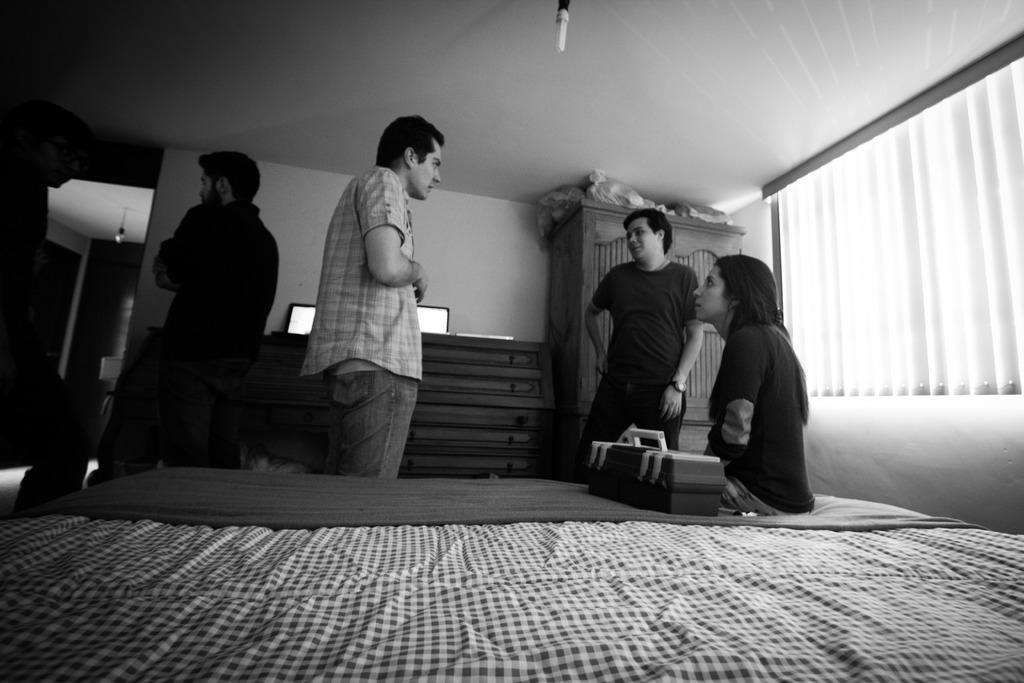In one or two sentences, can you explain what this image depicts? In this image I see 4 men standing and I see a woman who is sitting on the bed and there is a box beside to her. In the background I see the wall, cupboard, window and the light over here. 